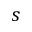<formula> <loc_0><loc_0><loc_500><loc_500>s</formula> 